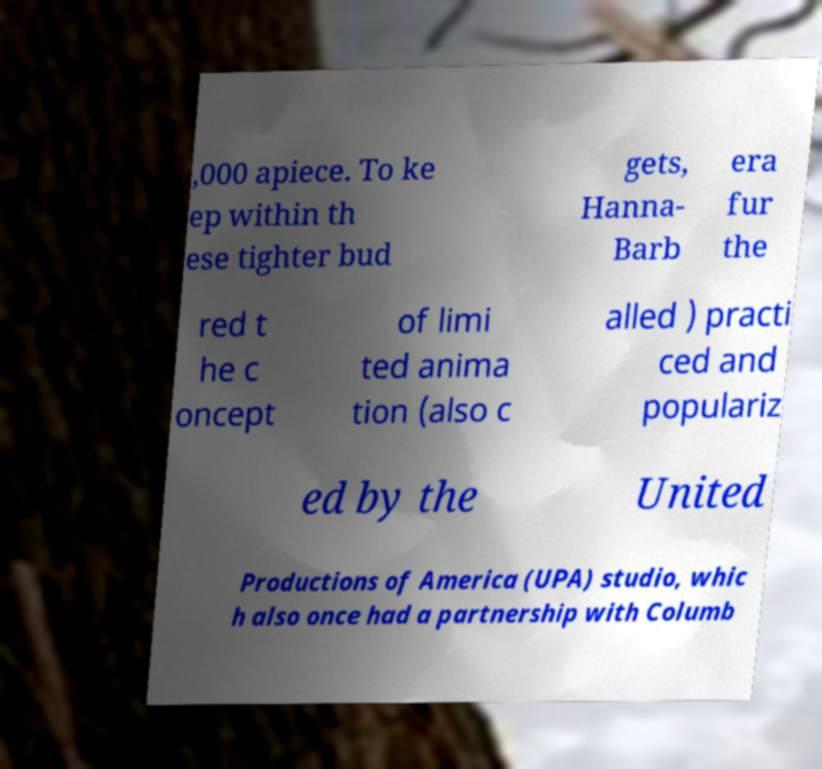Can you accurately transcribe the text from the provided image for me? ,000 apiece. To ke ep within th ese tighter bud gets, Hanna- Barb era fur the red t he c oncept of limi ted anima tion (also c alled ) practi ced and populariz ed by the United Productions of America (UPA) studio, whic h also once had a partnership with Columb 